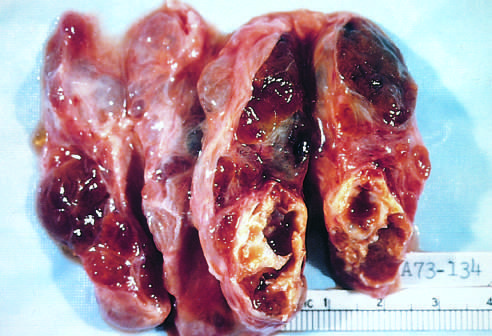what contains areas of fibrosis and cystic change?
Answer the question using a single word or phrase. The coarsely nodular gland 